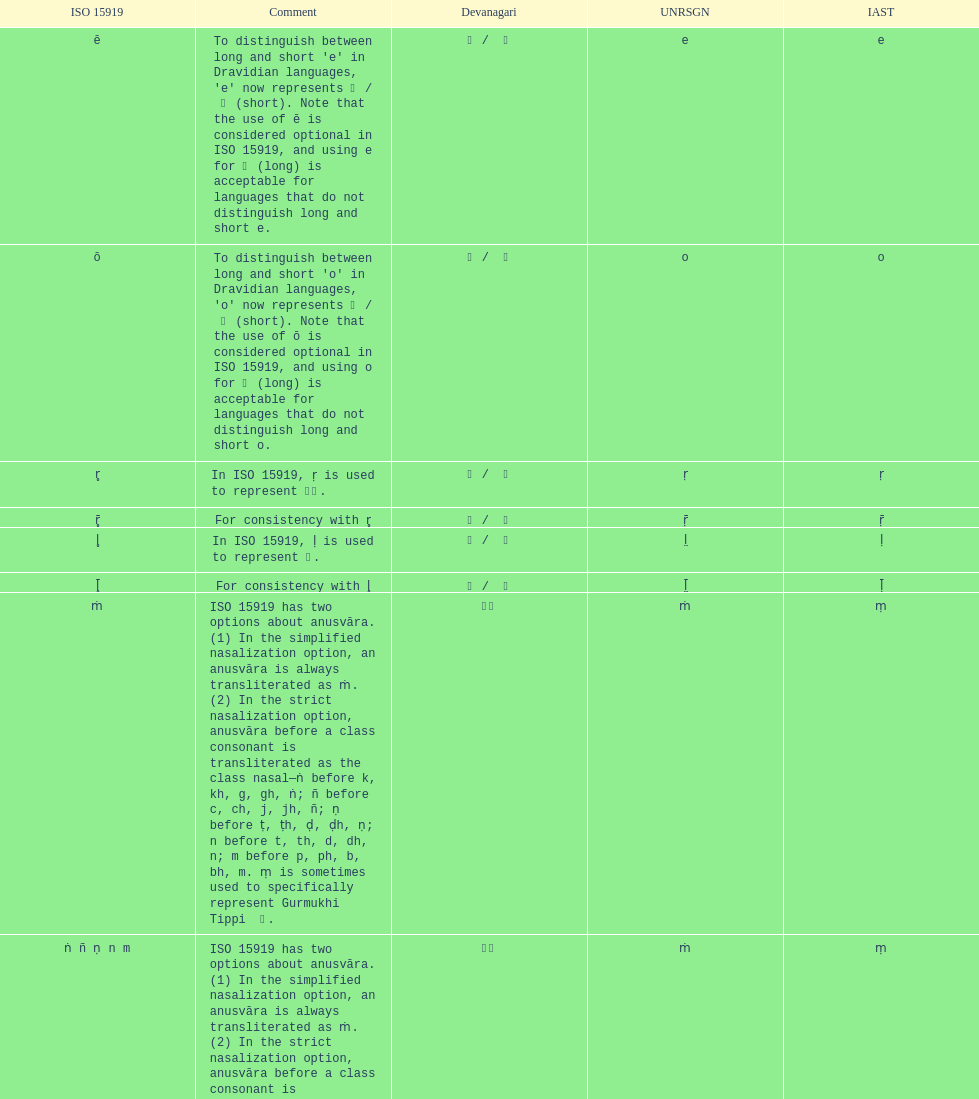Which devanagari transliteration is listed on the top of the table? ए / े. 